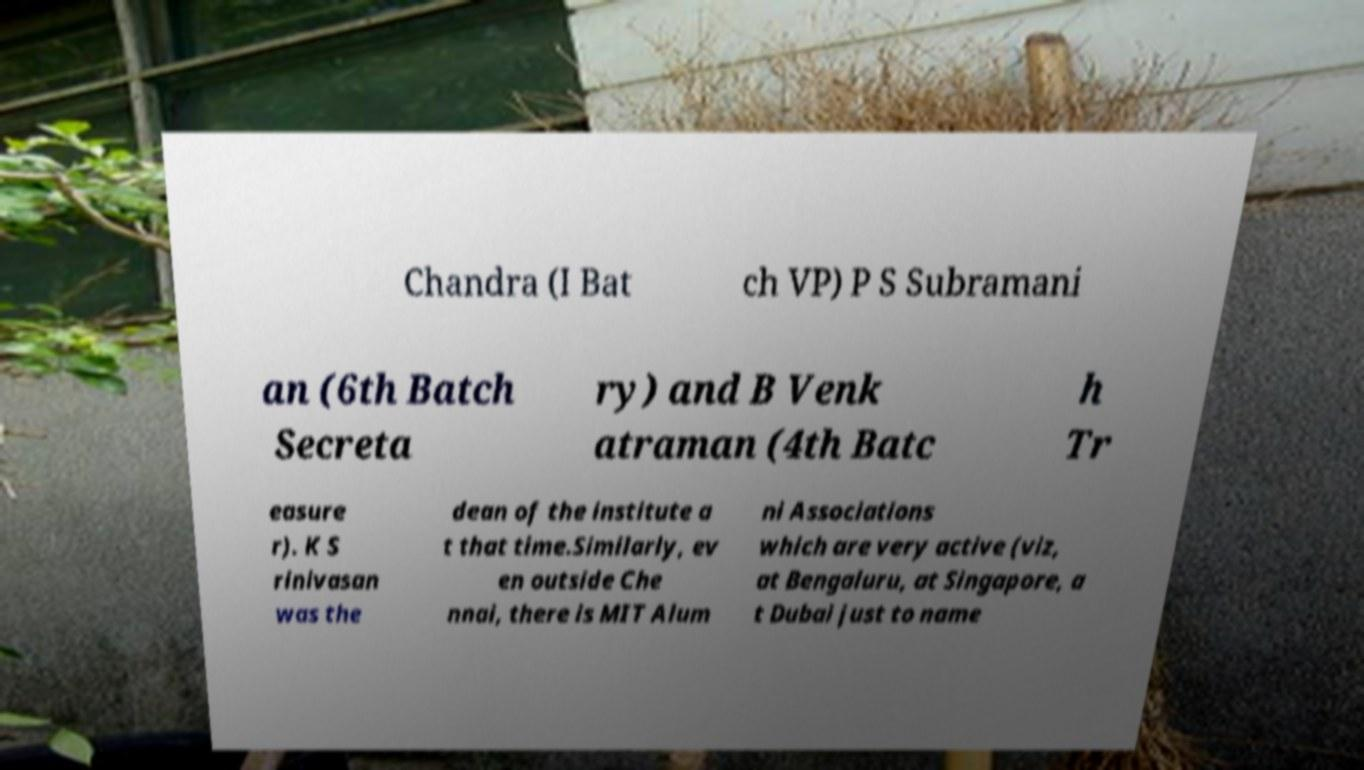For documentation purposes, I need the text within this image transcribed. Could you provide that? Chandra (I Bat ch VP) P S Subramani an (6th Batch Secreta ry) and B Venk atraman (4th Batc h Tr easure r). K S rinivasan was the dean of the institute a t that time.Similarly, ev en outside Che nnai, there is MIT Alum ni Associations which are very active (viz, at Bengaluru, at Singapore, a t Dubai just to name 